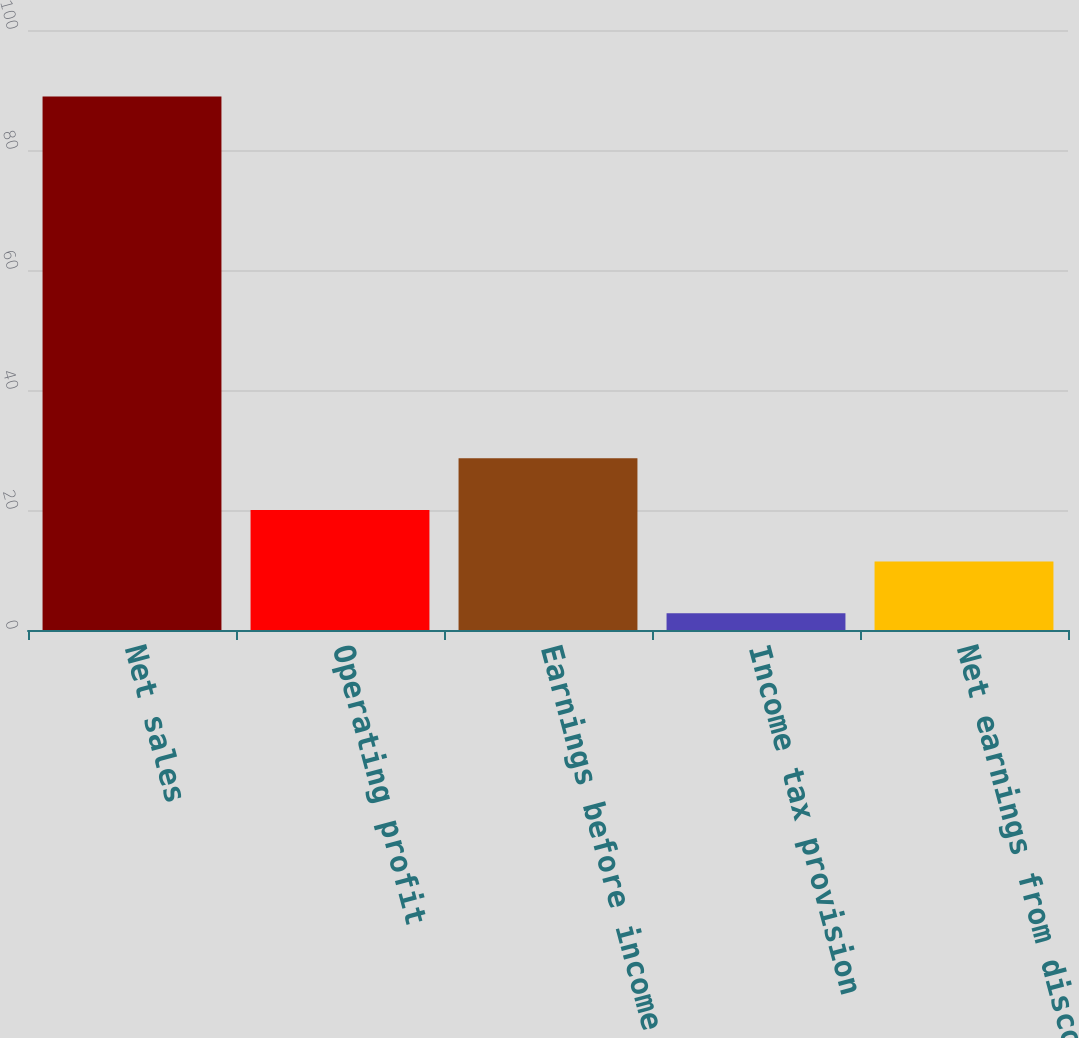Convert chart. <chart><loc_0><loc_0><loc_500><loc_500><bar_chart><fcel>Net sales<fcel>Operating profit<fcel>Earnings before income tax<fcel>Income tax provision<fcel>Net earnings from discontinued<nl><fcel>88.9<fcel>20.02<fcel>28.63<fcel>2.8<fcel>11.41<nl></chart> 